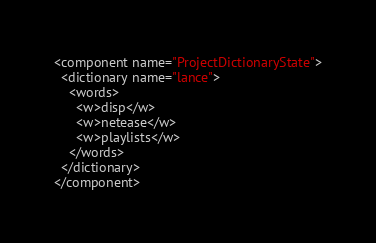Convert code to text. <code><loc_0><loc_0><loc_500><loc_500><_XML_><component name="ProjectDictionaryState">
  <dictionary name="lance">
    <words>
      <w>disp</w>
      <w>netease</w>
      <w>playlists</w>
    </words>
  </dictionary>
</component></code> 